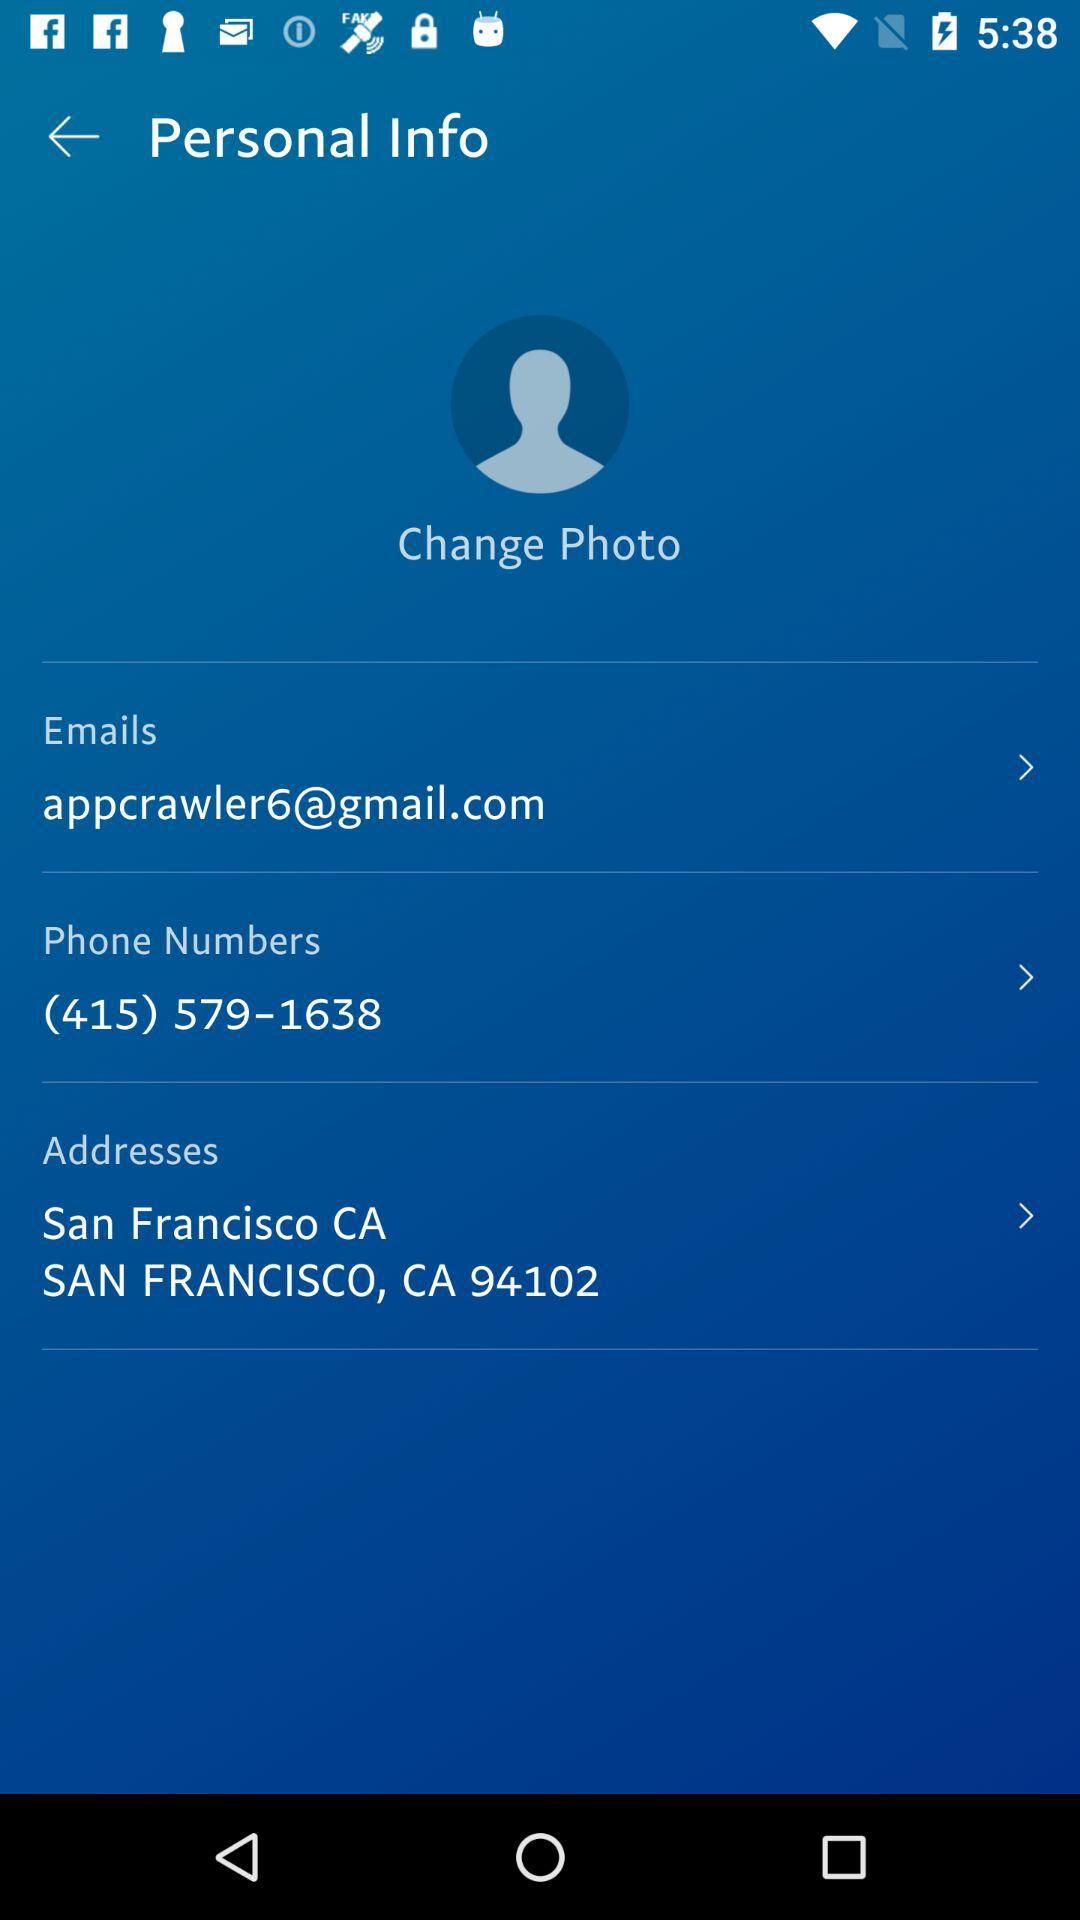What is the mentioned phone number there? The mentioned phone number is (415) 579-1638. 